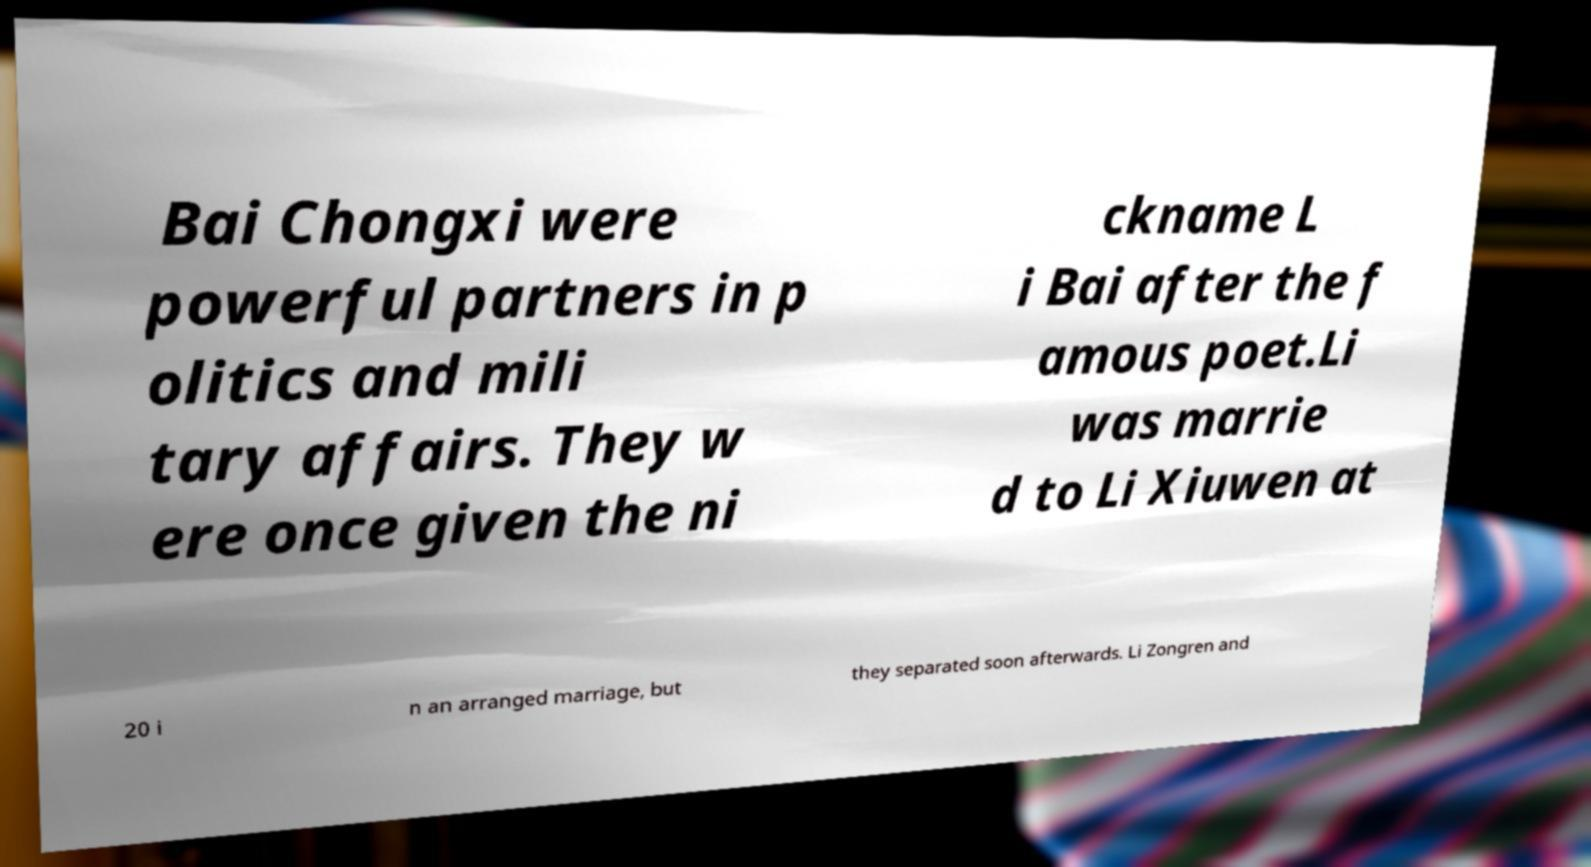Please read and relay the text visible in this image. What does it say? Bai Chongxi were powerful partners in p olitics and mili tary affairs. They w ere once given the ni ckname L i Bai after the f amous poet.Li was marrie d to Li Xiuwen at 20 i n an arranged marriage, but they separated soon afterwards. Li Zongren and 